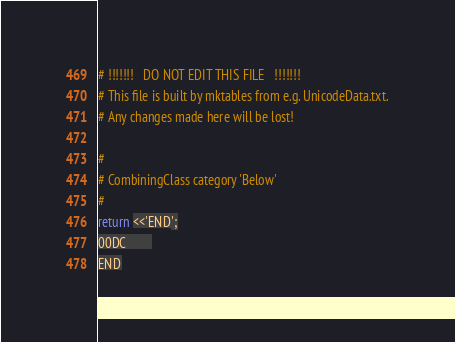<code> <loc_0><loc_0><loc_500><loc_500><_Perl_># !!!!!!!   DO NOT EDIT THIS FILE   !!!!!!! 
# This file is built by mktables from e.g. UnicodeData.txt.
# Any changes made here will be lost!

#
# CombiningClass category 'Below'
#
return <<'END';
00DC		
END
</code> 